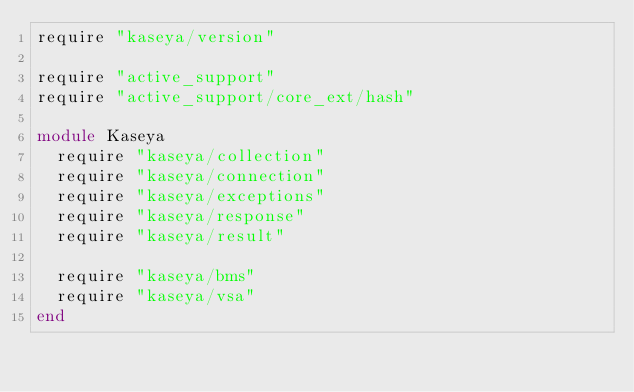Convert code to text. <code><loc_0><loc_0><loc_500><loc_500><_Ruby_>require "kaseya/version"

require "active_support"
require "active_support/core_ext/hash"

module Kaseya
  require "kaseya/collection"
  require "kaseya/connection"
  require "kaseya/exceptions"
  require "kaseya/response"
  require "kaseya/result"

  require "kaseya/bms"
  require "kaseya/vsa"
end
</code> 